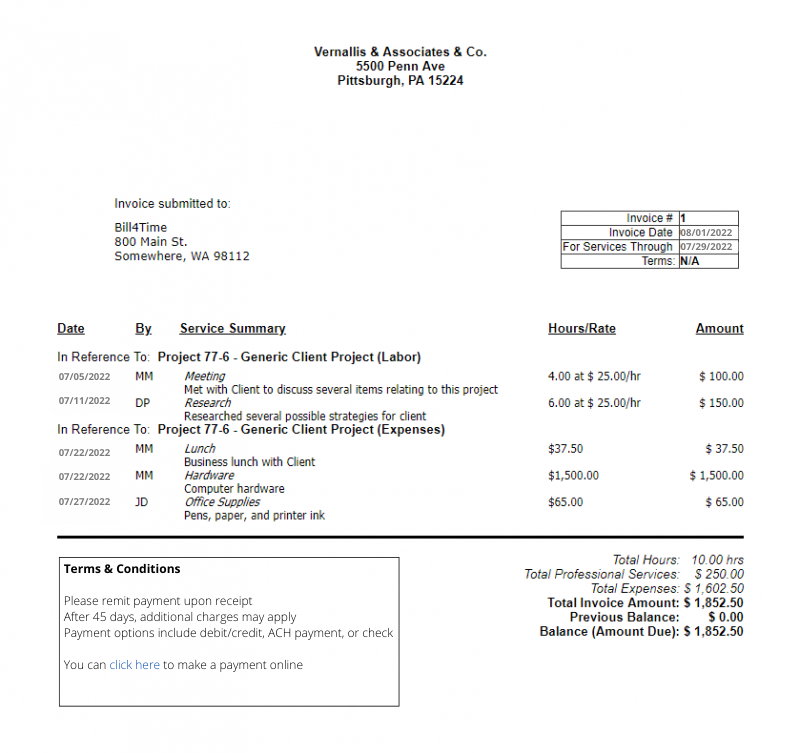extract  a list of all order items on that invoice, stating their Quantity, unit price and total amount the following json format: 
```
{{
    \"TabOrderItems\": [
        {{
            \"OrdItmArticleNo\": \"\",
            \"OrdItmArticleDescription\": \"\",
            \"OrdItmQuantity\": 2.0,
            \"OrdItemSingleNetAmount\": 3.34,
            \"OrdItemTotalNetAmount\": 4.23
        }}
    ]
}}
```

Include only goods and services, ignore shipping fees, taxes etc.
Only use the provided data. If you don't find some of the values within the provided data leave it blank.
 Based on the invoice image provided, the JSON format for the order items would be as follows:

```json
{
    "TabOrderItems": [
        {
            "OrdItmArticleNo": "",
            "OrdItmArticleDescription": "Research",
            "OrdItmQuantity": 6.0,
            "OrdItemSingleNetAmount": 25.00,
            "OrdItemTotalNetAmount": 150.00
        },
        {
            "OrdItmArticleNo": "",
            "OrdItmArticleDescription": "Lunch - Generic Client Project (Expenses)",
            "OrdItmQuantity": 1.0,
            "OrdItemSingleNetAmount": 37.50,
            "OrdItemTotalNetAmount": 37.50
        },
        {
            "OrdItmArticleNo": "",
            "OrdItmArticleDescription": "Hardware",
            "OrdItmQuantity": 1.0,
            "OrdItemSingleNetAmount": 1500.00,
            "OrdItemTotalNetAmount": 1500.00
        },
        {
            "OrdItmArticleNo": "",
            "OrdItmArticleDescription": "Office Supplies",
            "OrdItmQuantity": 1.0,
            "OrdItemSingleNetAmount": 65.00,
            "OrdItemTotalNetAmount": 65.00
        }
    ]
}
```

I left the `OrdItmArticleNo` fields blank since there are no article numbers provided on the invoice. The quantities were inferred based on the context, assuming each line item represents a single quantity except for "Research" which is quantified by hours worked. The unit price for "Research" is derived from the hourly rate, and the total net amounts match those listed in the invoice's Amount column. Other charges such as taxes and shipping fees (if any) were omitted as instructed. 